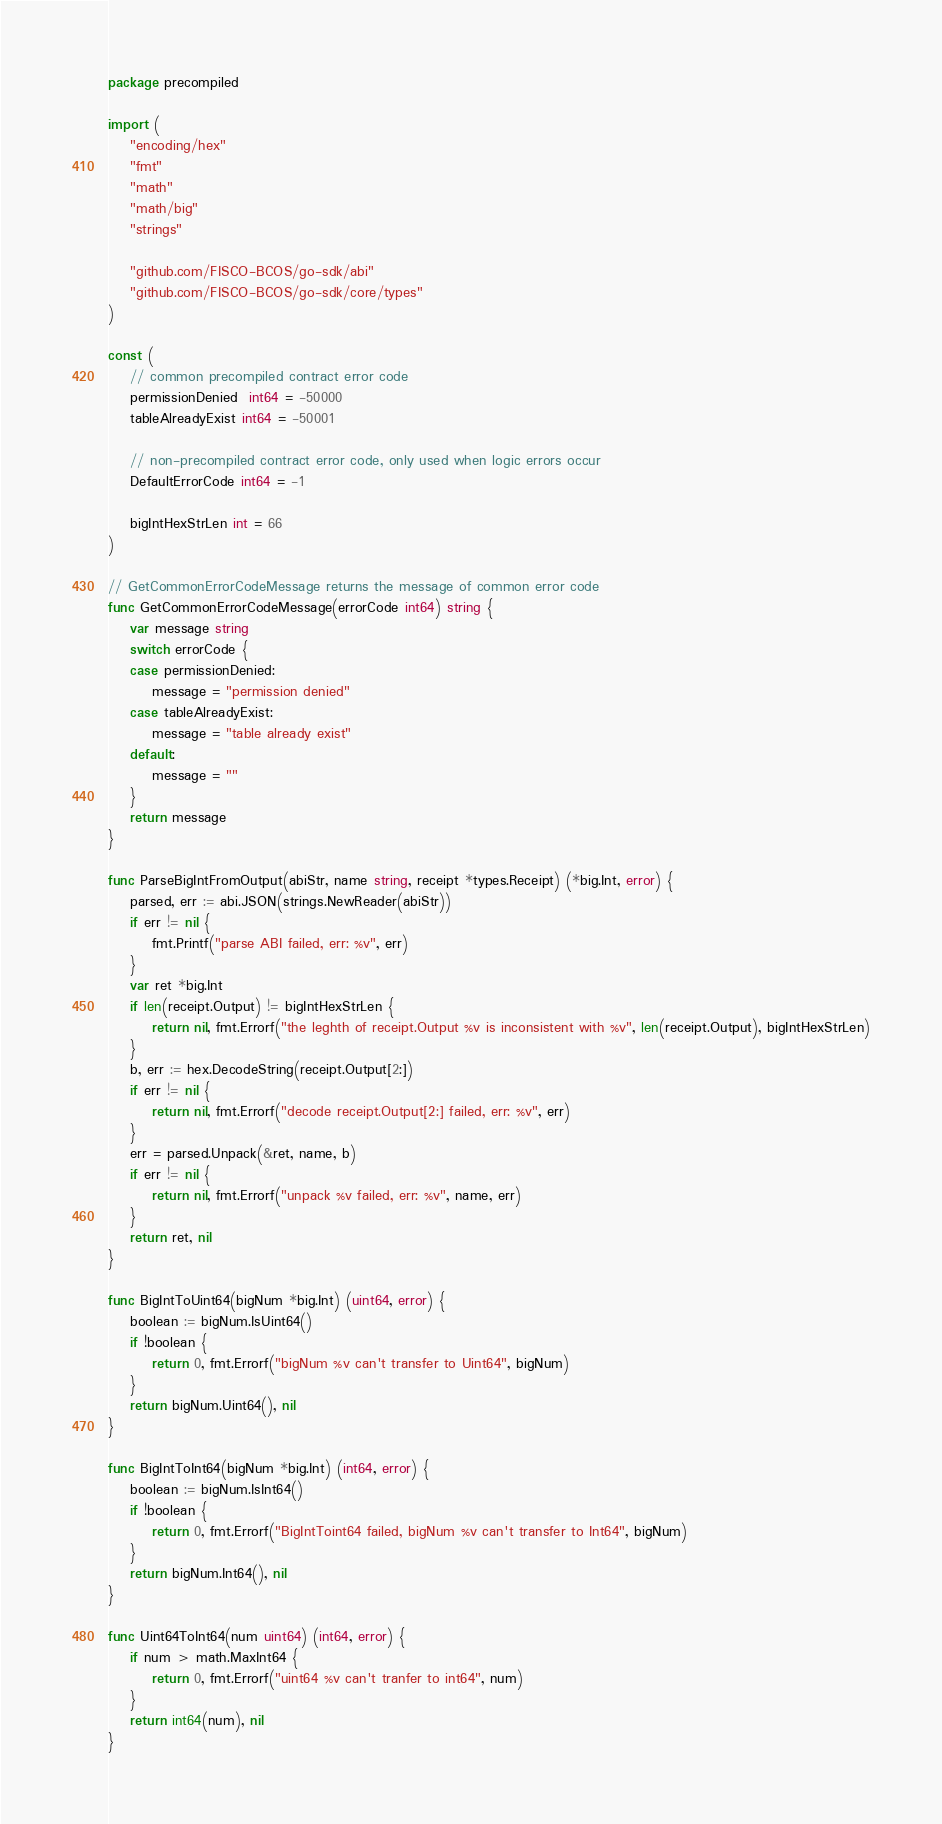<code> <loc_0><loc_0><loc_500><loc_500><_Go_>package precompiled

import (
	"encoding/hex"
	"fmt"
	"math"
	"math/big"
	"strings"

	"github.com/FISCO-BCOS/go-sdk/abi"
	"github.com/FISCO-BCOS/go-sdk/core/types"
)

const (
	// common precompiled contract error code
	permissionDenied  int64 = -50000
	tableAlreadyExist int64 = -50001

	// non-precompiled contract error code, only used when logic errors occur
	DefaultErrorCode int64 = -1

	bigIntHexStrLen int = 66
)

// GetCommonErrorCodeMessage returns the message of common error code
func GetCommonErrorCodeMessage(errorCode int64) string {
	var message string
	switch errorCode {
	case permissionDenied:
		message = "permission denied"
	case tableAlreadyExist:
		message = "table already exist"
	default:
		message = ""
	}
	return message
}

func ParseBigIntFromOutput(abiStr, name string, receipt *types.Receipt) (*big.Int, error) {
	parsed, err := abi.JSON(strings.NewReader(abiStr))
	if err != nil {
		fmt.Printf("parse ABI failed, err: %v", err)
	}
	var ret *big.Int
	if len(receipt.Output) != bigIntHexStrLen {
		return nil, fmt.Errorf("the leghth of receipt.Output %v is inconsistent with %v", len(receipt.Output), bigIntHexStrLen)
	}
	b, err := hex.DecodeString(receipt.Output[2:])
	if err != nil {
		return nil, fmt.Errorf("decode receipt.Output[2:] failed, err: %v", err)
	}
	err = parsed.Unpack(&ret, name, b)
	if err != nil {
		return nil, fmt.Errorf("unpack %v failed, err: %v", name, err)
	}
	return ret, nil
}

func BigIntToUint64(bigNum *big.Int) (uint64, error) {
	boolean := bigNum.IsUint64()
	if !boolean {
		return 0, fmt.Errorf("bigNum %v can't transfer to Uint64", bigNum)
	}
	return bigNum.Uint64(), nil
}

func BigIntToInt64(bigNum *big.Int) (int64, error) {
	boolean := bigNum.IsInt64()
	if !boolean {
		return 0, fmt.Errorf("BigIntToint64 failed, bigNum %v can't transfer to Int64", bigNum)
	}
	return bigNum.Int64(), nil
}

func Uint64ToInt64(num uint64) (int64, error) {
	if num > math.MaxInt64 {
		return 0, fmt.Errorf("uint64 %v can't tranfer to int64", num)
	}
	return int64(num), nil
}
</code> 